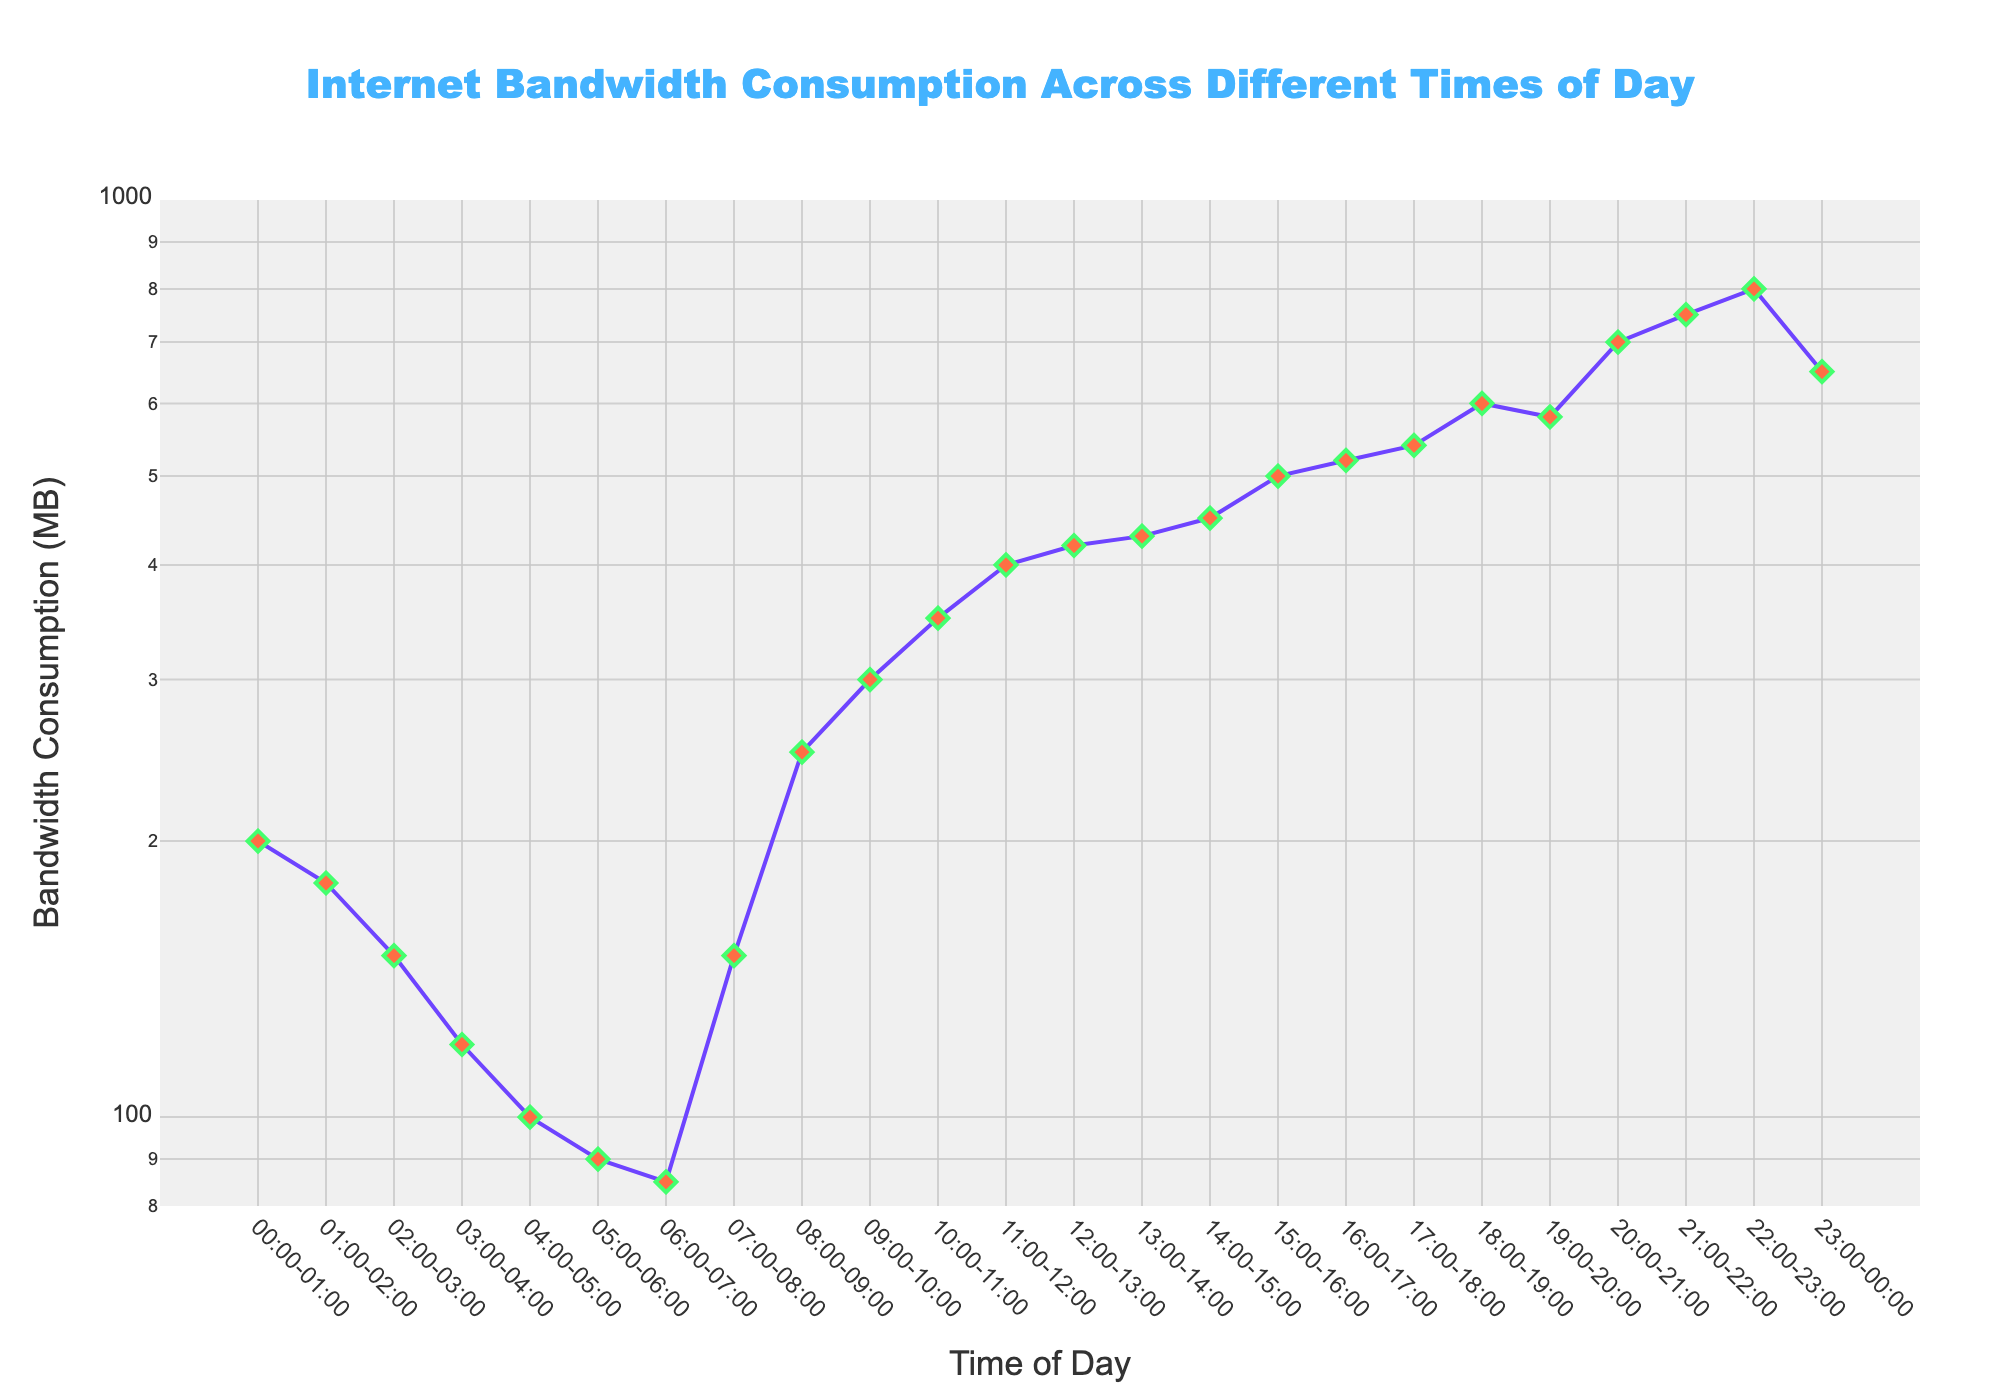What is the title of the plot? The title of the plot is located at the top center of the figure. It reads "Internet Bandwidth Consumption Across Different Times of Day".
Answer: Internet Bandwidth Consumption Across Different Times of Day How much bandwidth is consumed between 10:00-11:00? To find this, look for the point on the x-axis labeled "10:00-11:00" and read the corresponding value on the y-axis. The bandwidth consumption is 350 MB.
Answer: 350 MB What is the general trend of bandwidth consumption from 00:00 to 23:00? The general trend can be observed by looking at how the line plot progresses from left to right across the x-axis. Initially, from 00:00 to around 06:00, bandwidth consumption decreases. After 06:00, there is a sharp increase, peaking in the late evening.
Answer: decreasing, then increasing What is the difference in bandwidth consumption between the peak time and the lowest time? Firstly, identify the peak bandwidth consumption at the highest y-axis point, which is 800 MB during 22:00-23:00. The lowest bandwidth consumption occurs at 06:00-07:00 with 85 MB. Subtract 85 from 800 to find the difference.
Answer: 715 MB During which time interval is bandwidth consumption the highest? Find the highest point on the y-axis and check the corresponding x-axis interval. The highest bandwidth consumption, 800 MB, occurs at 22:00-23:00.
Answer: 22:00-23:00 How does bandwidth consumption at 18:00-19:00 compare to that at 23:00-00:00? Look at the y-axis values for both time intervals. At 18:00-19:00, consumption is 600 MB, while at 23:00-00:00, it is 650 MB. Therefore, consumption is 50 MB higher at 23:00-00:00.
Answer: 50 MB higher Is there any time when bandwidth consumption is exactly 500 MB? If yes, when? Check the y-axis for a data point that hits exactly 500 MB. The plot indicates 500 MB consumption at 15:00-16:00.
Answer: 15:00-16:00 What is the range of the y-axis on the plot? The y-axis is on a logarithmic scale, ranging from approximately 80 MB (10^1.9) to 1000 MB (10^3).
Answer: 80 MB to 1000 MB How many time intervals are there in the plot? Count the number of distinct labels on the x-axis representing different time intervals. There are 24 intervals shown on the plot.
Answer: 24 